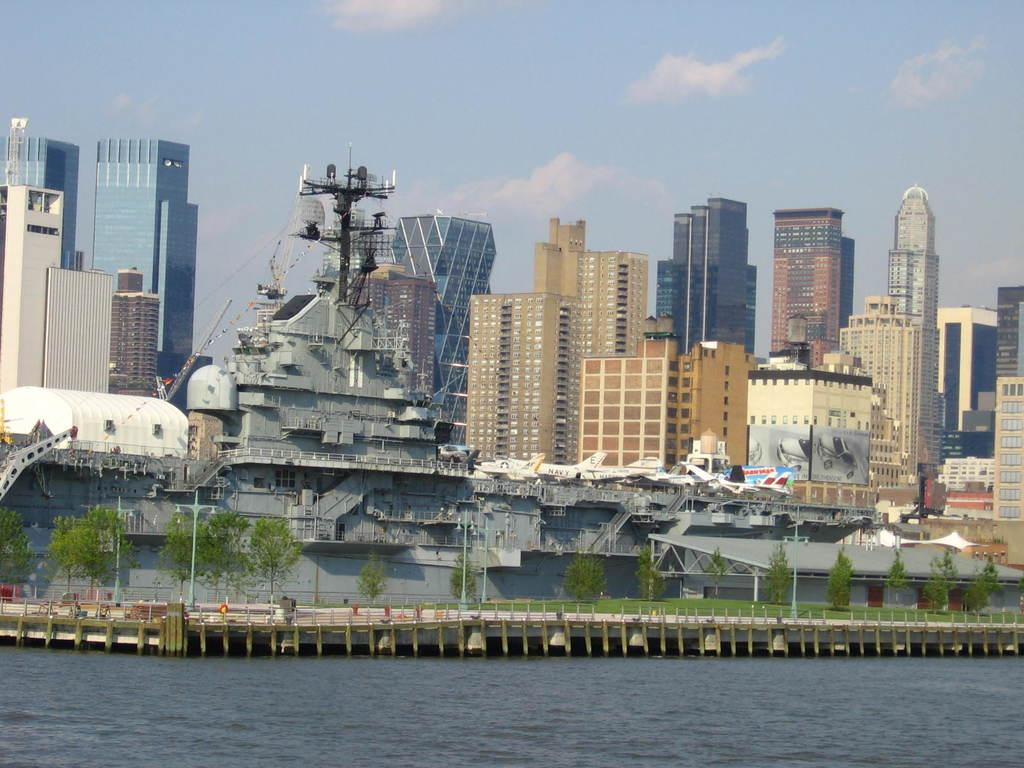What type of structures can be seen in the background of the image? There are buildings in the background of the image. What is visible above the buildings in the image? There is a sky visible in the image. What is the main subject of the image? There is a ship in the image. What is present at the bottom of the image? There is water at the bottom of the image. What type of vegetation can be seen in the image? There are trees in the image. What type of gun is being used by the expert in the image? There is no gun or expert present in the image. 